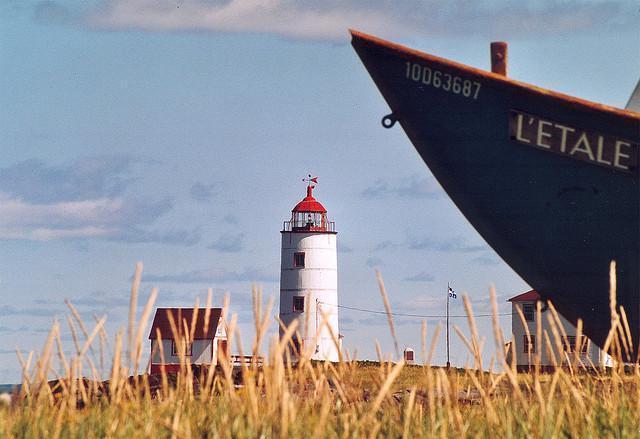How many chairs don't have a dog on them?
Give a very brief answer. 0. 